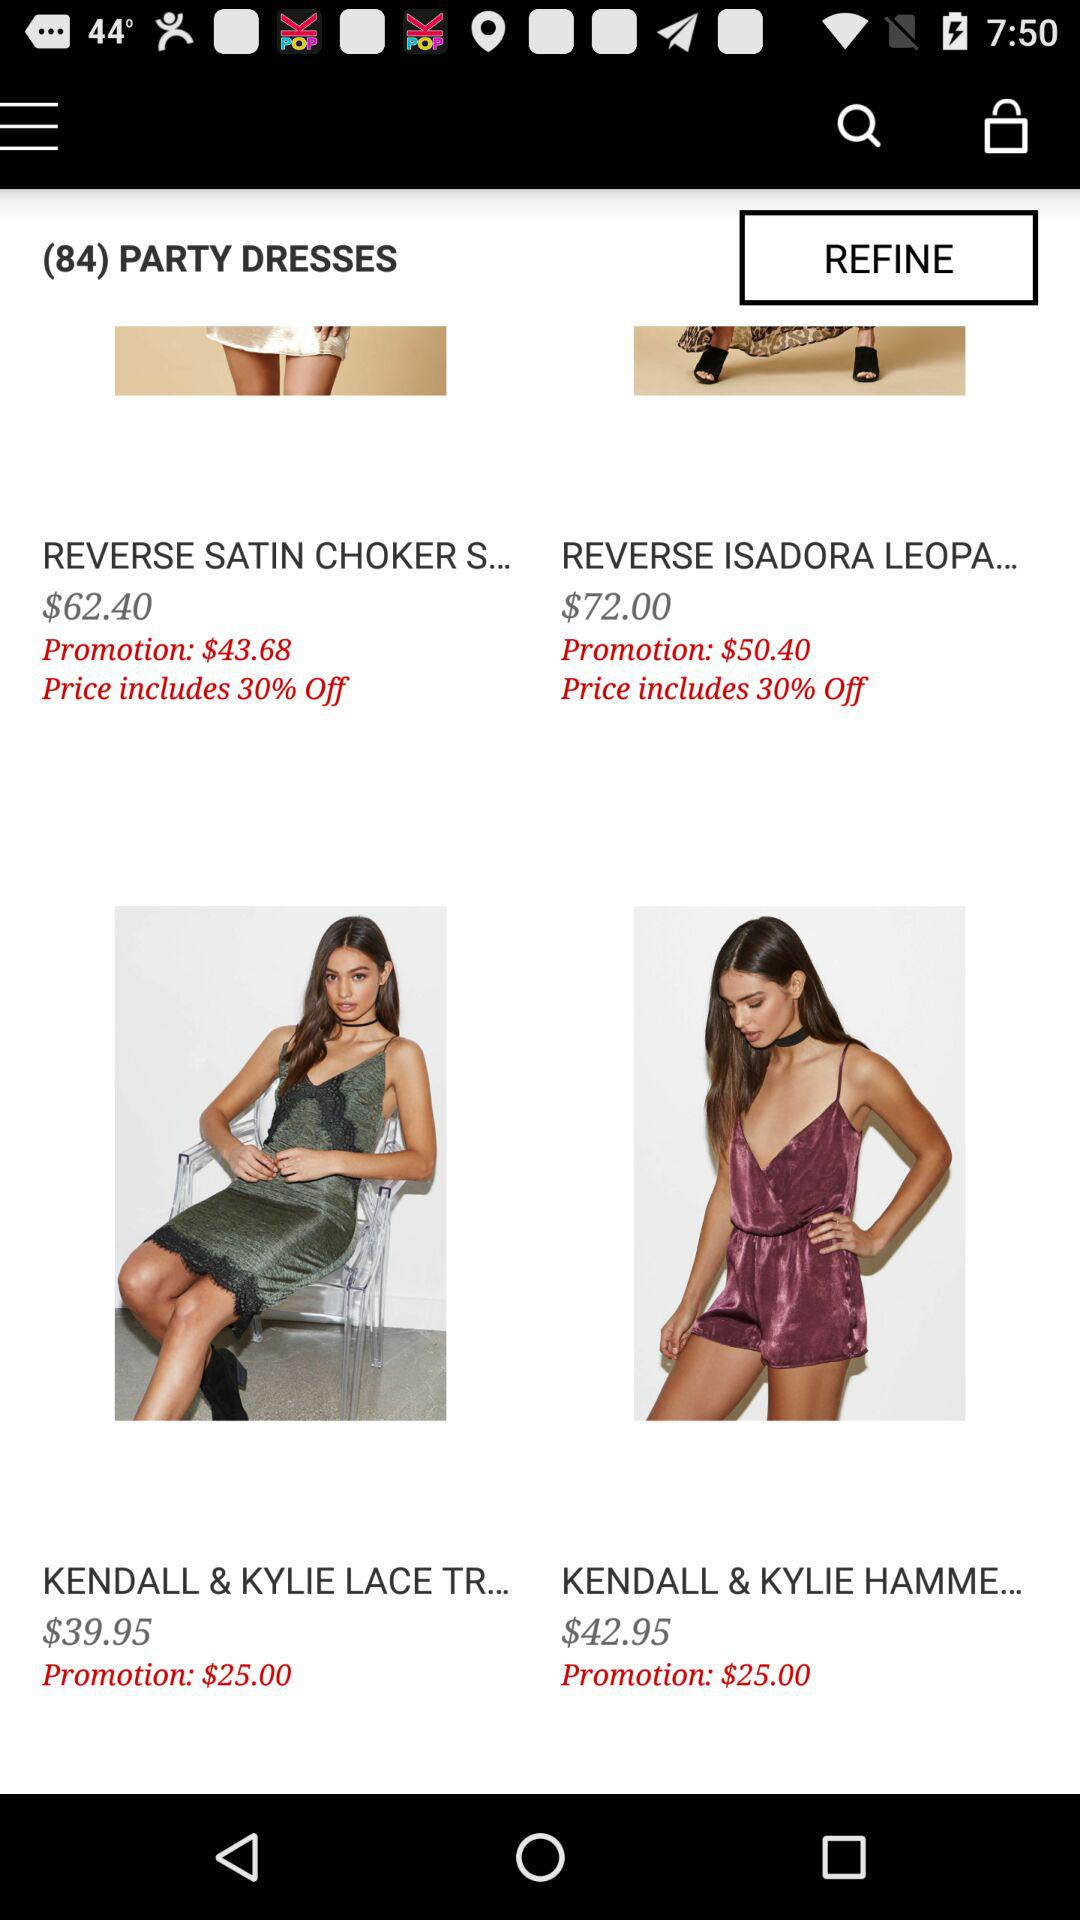Which items are found in the bag?
When the provided information is insufficient, respond with <no answer>. <no answer> 